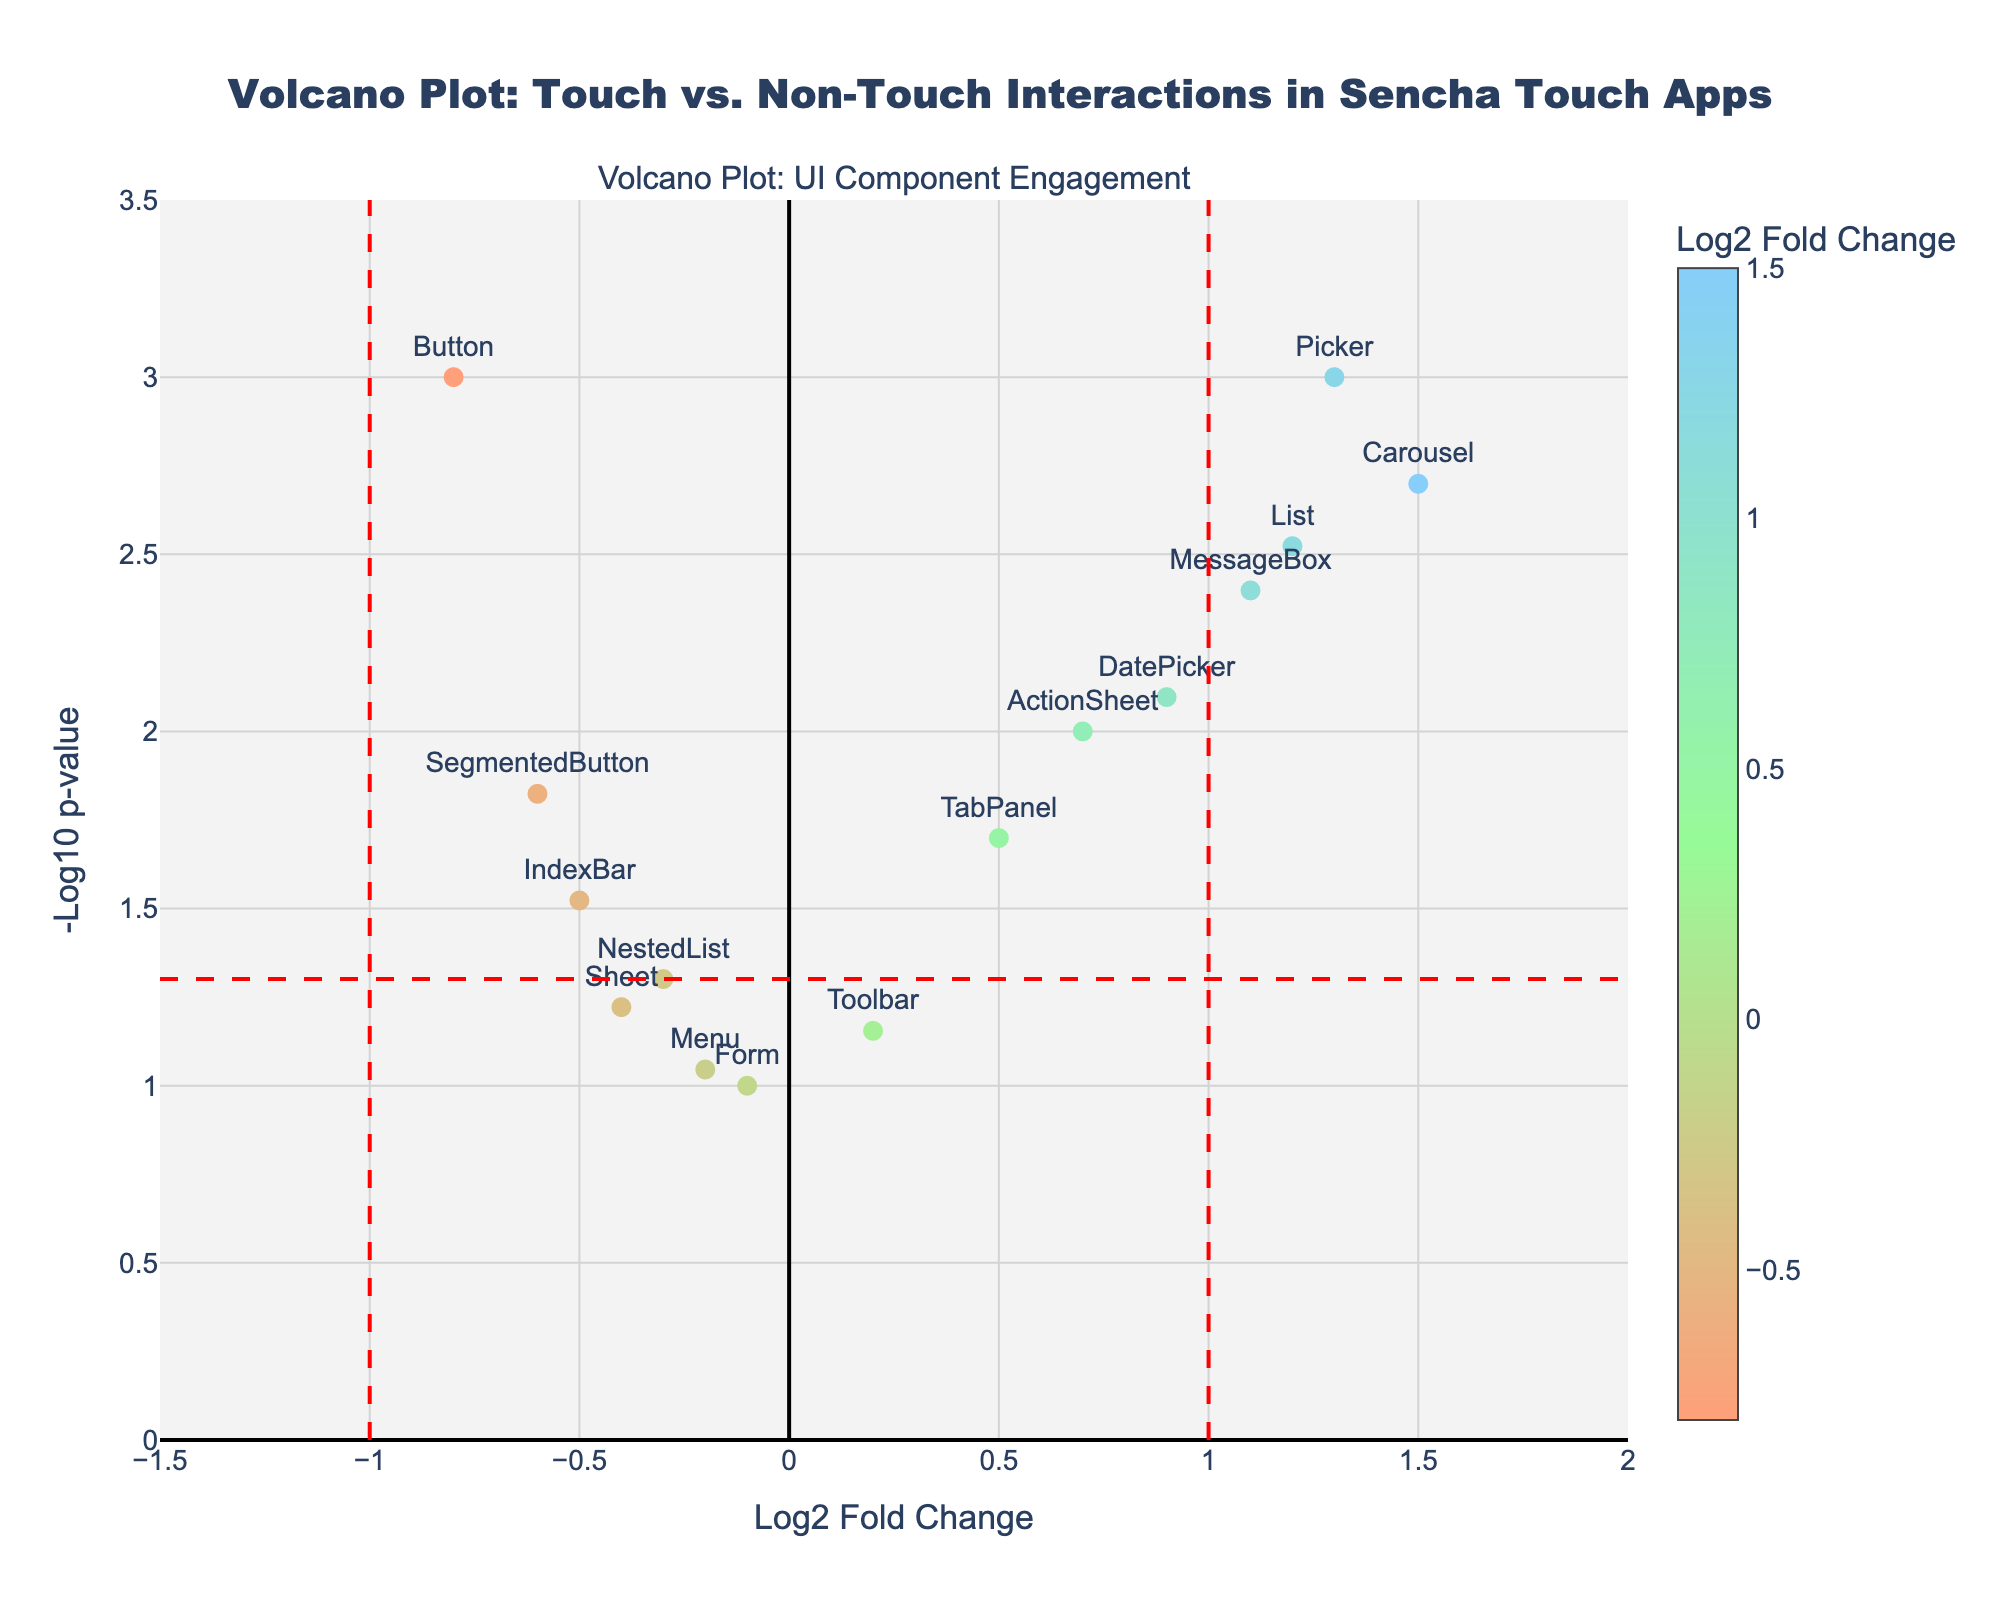What is the title of the plot? The title is visible at the top center of the plot. It reads "Volcano Plot: Touch vs. Non-Touch Interactions in Sencha Touch Apps"
Answer: Volcano Plot: Touch vs. Non-Touch Interactions in Sencha Touch Apps What do the colors of the data points represent? The colors are defined by the Log2 Fold Change values and are shown on a colorscale. The colorbar explains that the colors correlate with the Log2 Fold Change values.
Answer: Log2 Fold Change Which UI component has the highest negative Log2 fold change? The component labeled with the most negative Log2 fold change on the x-axis gives the answer. We can see "Button" is the furthest to the left.
Answer: Button How many data points are displayed in the plot? Count the number of distinct markers present in the scatter plot. Each data point represents a specific UI component. There are 15 data points.
Answer: 15 What is the Log2 Fold Change value for the component "SegmentedButton"? Identify the marker for "SegmentedButton" and read its x-axis value, which represents the Log2 Fold Change. The marker is around -0.6 on the Log2 Fold Change axis.
Answer: -0.6 Which component shows the highest engagement based on Log2 fold change? The component with the highest positive Log2 fold change will show the highest engagement. The "Carousel" component has the highest positive value at 1.5.
Answer: Carousel Which component has the lowest p-value? Find the component with the highest -Log10 p-value, which represents the lowest p-value. Picker is at the highest point on the y-axis. Its p-value is 0.001.
Answer: Picker What are the threshold lines in the plot? Two different types of lines are present. Vertical red dashed lines at Log2 Fold Change values of -1 and 1, and a horizontal red dashed line at p-value threshold -Log10(p-value) = 1.301, which corresponds to p=0.05.
Answer: Log2 FC at -1 and 1, p-value at 0.05 Compare the significance levels of the "MessageBox" and "SegmentedButton" components. Compare their p-values by looking at their -Log10p values on the y-axis. "MessageBox" points higher with -Log10p value around 2.4 vs. "SegmentedButton" around 1.8. Hence, "MessageBox" is more significant.
Answer: MessageBox > SegmentedButton 